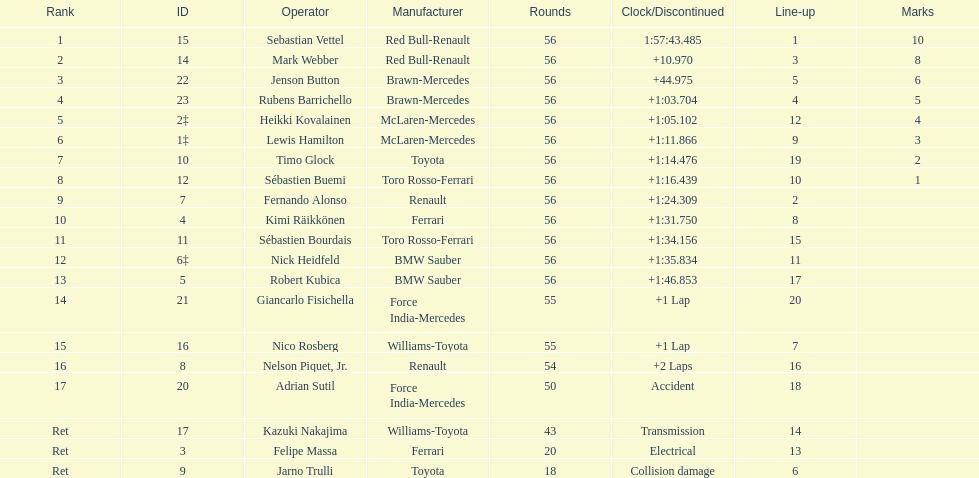Which driver is the exclusive driver who retired as a result of collision damage? Jarno Trulli. 